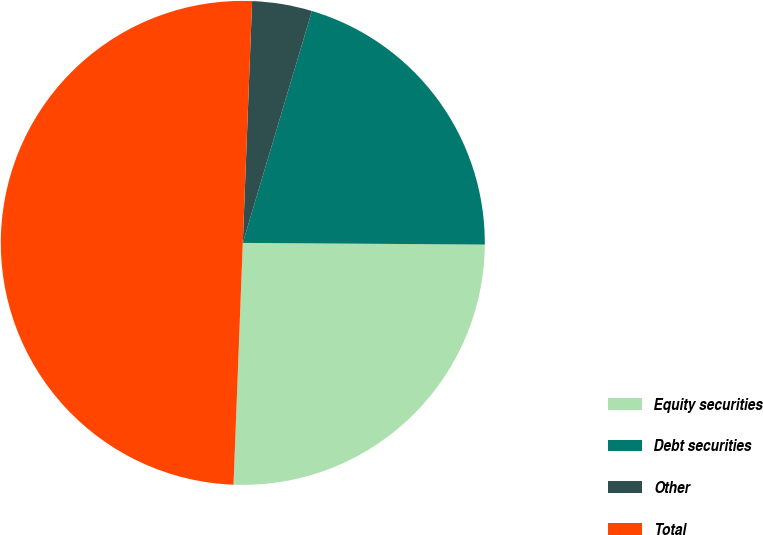Convert chart. <chart><loc_0><loc_0><loc_500><loc_500><pie_chart><fcel>Equity securities<fcel>Debt securities<fcel>Other<fcel>Total<nl><fcel>25.5%<fcel>20.5%<fcel>4.0%<fcel>50.0%<nl></chart> 